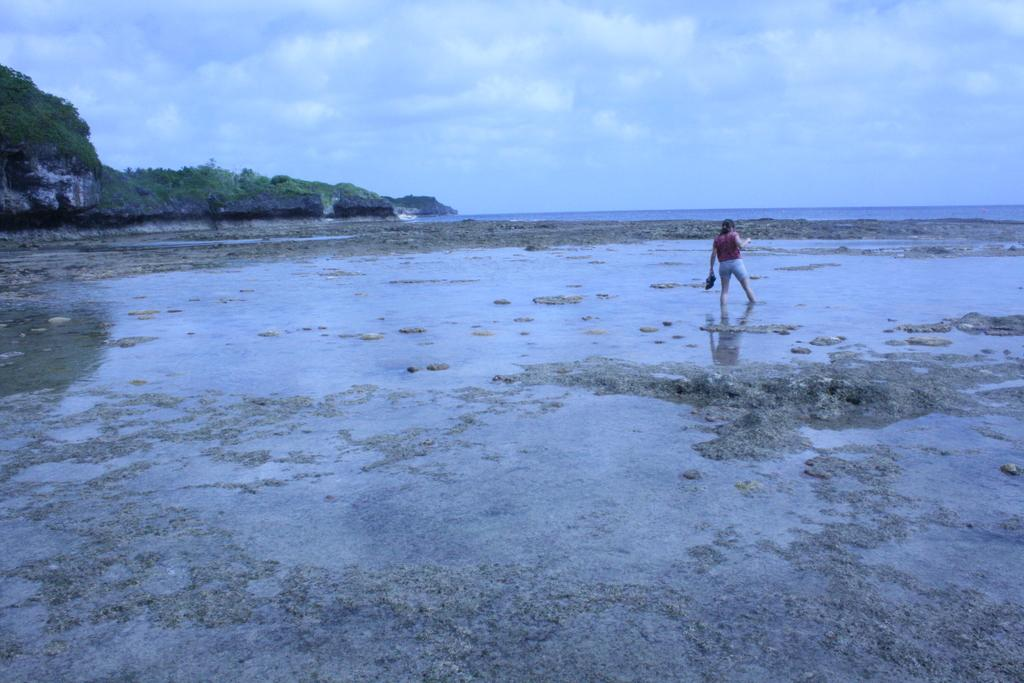What is in the foreground of the image? There is water and stones in the foreground of the image. What is the girl in the image doing? A girl is walking in the water in the foreground of the image. What can be seen in the background of the image? There are cliffs, water, and the sky visible in the background of the image. What is the condition of the sky in the background of the image? The sky is visible in the background of the image, and there are clouds present. What type of hat is the girl wearing in the image? There is no hat visible on the girl in the image. What subject is the girl teaching in the class in the image? There is no class or subject being taught in the image; it features a girl walking in the water. 